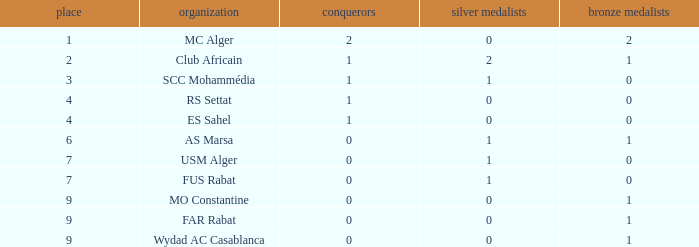Which Rank has a Third of 2, and Winners smaller than 2? None. 